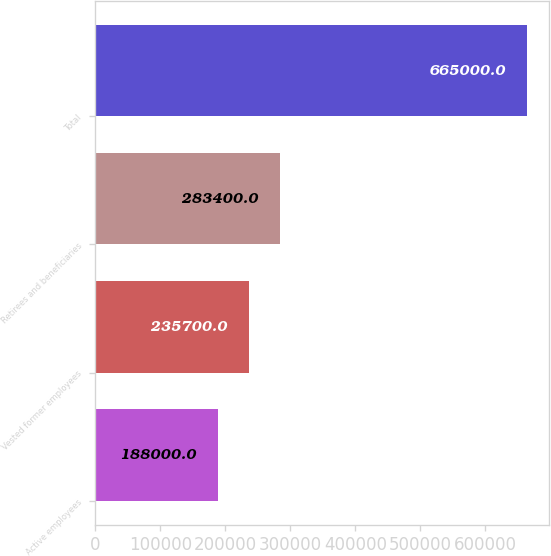Convert chart to OTSL. <chart><loc_0><loc_0><loc_500><loc_500><bar_chart><fcel>Active employees<fcel>Vested former employees<fcel>Retirees and beneficiaries<fcel>Total<nl><fcel>188000<fcel>235700<fcel>283400<fcel>665000<nl></chart> 